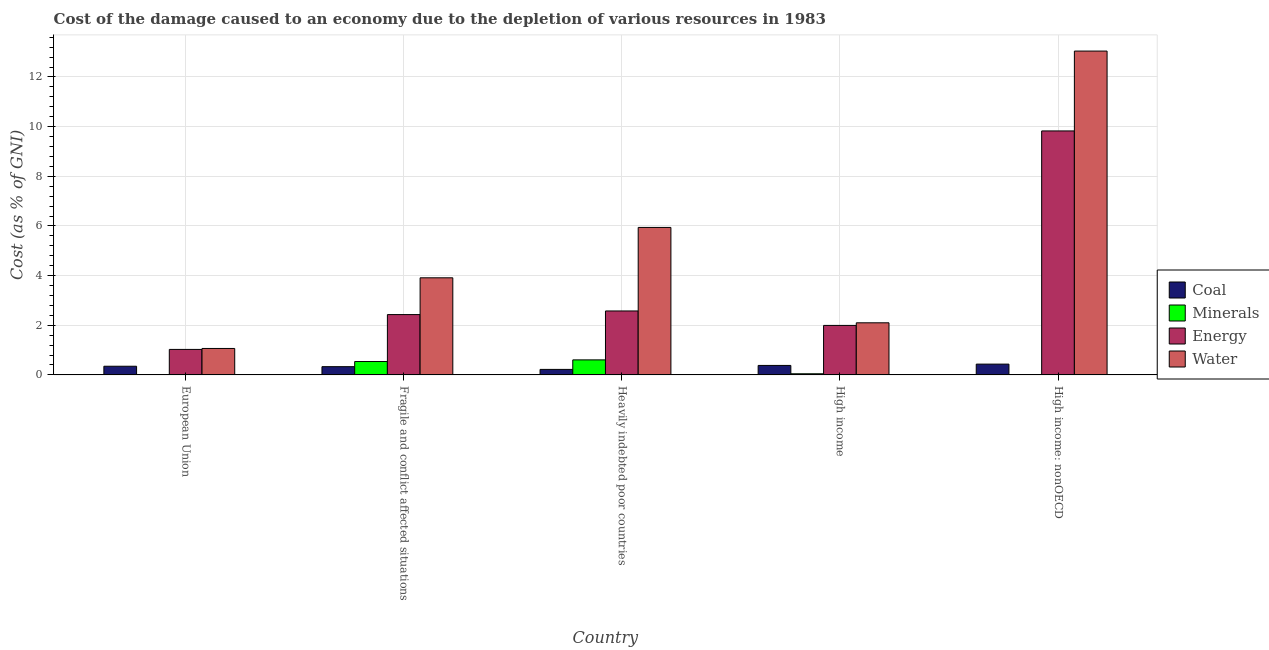How many bars are there on the 2nd tick from the left?
Offer a terse response. 4. In how many cases, is the number of bars for a given country not equal to the number of legend labels?
Give a very brief answer. 0. What is the cost of damage due to depletion of energy in Heavily indebted poor countries?
Your answer should be very brief. 2.58. Across all countries, what is the maximum cost of damage due to depletion of minerals?
Give a very brief answer. 0.61. Across all countries, what is the minimum cost of damage due to depletion of coal?
Make the answer very short. 0.22. In which country was the cost of damage due to depletion of minerals maximum?
Your answer should be very brief. Heavily indebted poor countries. In which country was the cost of damage due to depletion of minerals minimum?
Your response must be concise. European Union. What is the total cost of damage due to depletion of energy in the graph?
Your answer should be compact. 17.85. What is the difference between the cost of damage due to depletion of minerals in Fragile and conflict affected situations and that in High income?
Your answer should be compact. 0.49. What is the difference between the cost of damage due to depletion of water in High income and the cost of damage due to depletion of coal in Fragile and conflict affected situations?
Provide a short and direct response. 1.77. What is the average cost of damage due to depletion of water per country?
Your answer should be compact. 5.21. What is the difference between the cost of damage due to depletion of coal and cost of damage due to depletion of energy in Fragile and conflict affected situations?
Your response must be concise. -2.1. In how many countries, is the cost of damage due to depletion of energy greater than 12.4 %?
Provide a succinct answer. 0. What is the ratio of the cost of damage due to depletion of water in Heavily indebted poor countries to that in High income?
Offer a very short reply. 2.83. Is the difference between the cost of damage due to depletion of minerals in European Union and Heavily indebted poor countries greater than the difference between the cost of damage due to depletion of energy in European Union and Heavily indebted poor countries?
Give a very brief answer. Yes. What is the difference between the highest and the second highest cost of damage due to depletion of minerals?
Offer a terse response. 0.07. What is the difference between the highest and the lowest cost of damage due to depletion of water?
Offer a terse response. 11.98. Is the sum of the cost of damage due to depletion of energy in Fragile and conflict affected situations and High income greater than the maximum cost of damage due to depletion of water across all countries?
Provide a short and direct response. No. What does the 3rd bar from the left in High income represents?
Your answer should be compact. Energy. What does the 3rd bar from the right in High income: nonOECD represents?
Your answer should be very brief. Minerals. Are the values on the major ticks of Y-axis written in scientific E-notation?
Ensure brevity in your answer.  No. Does the graph contain any zero values?
Provide a succinct answer. No. Does the graph contain grids?
Provide a short and direct response. Yes. How many legend labels are there?
Ensure brevity in your answer.  4. What is the title of the graph?
Provide a short and direct response. Cost of the damage caused to an economy due to the depletion of various resources in 1983 . Does "Social Awareness" appear as one of the legend labels in the graph?
Your answer should be very brief. No. What is the label or title of the Y-axis?
Ensure brevity in your answer.  Cost (as % of GNI). What is the Cost (as % of GNI) in Coal in European Union?
Offer a very short reply. 0.35. What is the Cost (as % of GNI) of Minerals in European Union?
Make the answer very short. 0.01. What is the Cost (as % of GNI) of Energy in European Union?
Provide a short and direct response. 1.03. What is the Cost (as % of GNI) of Water in European Union?
Ensure brevity in your answer.  1.07. What is the Cost (as % of GNI) in Coal in Fragile and conflict affected situations?
Give a very brief answer. 0.33. What is the Cost (as % of GNI) in Minerals in Fragile and conflict affected situations?
Your answer should be compact. 0.54. What is the Cost (as % of GNI) in Energy in Fragile and conflict affected situations?
Provide a short and direct response. 2.43. What is the Cost (as % of GNI) of Water in Fragile and conflict affected situations?
Your response must be concise. 3.91. What is the Cost (as % of GNI) in Coal in Heavily indebted poor countries?
Offer a terse response. 0.22. What is the Cost (as % of GNI) of Minerals in Heavily indebted poor countries?
Offer a terse response. 0.61. What is the Cost (as % of GNI) in Energy in Heavily indebted poor countries?
Provide a short and direct response. 2.58. What is the Cost (as % of GNI) of Water in Heavily indebted poor countries?
Give a very brief answer. 5.94. What is the Cost (as % of GNI) in Coal in High income?
Offer a terse response. 0.38. What is the Cost (as % of GNI) of Minerals in High income?
Your answer should be very brief. 0.05. What is the Cost (as % of GNI) of Energy in High income?
Provide a short and direct response. 1.99. What is the Cost (as % of GNI) of Water in High income?
Your answer should be very brief. 2.1. What is the Cost (as % of GNI) in Coal in High income: nonOECD?
Offer a very short reply. 0.43. What is the Cost (as % of GNI) of Minerals in High income: nonOECD?
Your response must be concise. 0.01. What is the Cost (as % of GNI) of Energy in High income: nonOECD?
Your answer should be compact. 9.83. What is the Cost (as % of GNI) of Water in High income: nonOECD?
Provide a succinct answer. 13.04. Across all countries, what is the maximum Cost (as % of GNI) of Coal?
Give a very brief answer. 0.43. Across all countries, what is the maximum Cost (as % of GNI) of Minerals?
Keep it short and to the point. 0.61. Across all countries, what is the maximum Cost (as % of GNI) in Energy?
Offer a very short reply. 9.83. Across all countries, what is the maximum Cost (as % of GNI) in Water?
Your response must be concise. 13.04. Across all countries, what is the minimum Cost (as % of GNI) of Coal?
Provide a short and direct response. 0.22. Across all countries, what is the minimum Cost (as % of GNI) of Minerals?
Keep it short and to the point. 0.01. Across all countries, what is the minimum Cost (as % of GNI) in Energy?
Give a very brief answer. 1.03. Across all countries, what is the minimum Cost (as % of GNI) in Water?
Provide a short and direct response. 1.07. What is the total Cost (as % of GNI) in Coal in the graph?
Your response must be concise. 1.72. What is the total Cost (as % of GNI) of Minerals in the graph?
Make the answer very short. 1.21. What is the total Cost (as % of GNI) of Energy in the graph?
Offer a very short reply. 17.85. What is the total Cost (as % of GNI) of Water in the graph?
Provide a succinct answer. 26.06. What is the difference between the Cost (as % of GNI) in Coal in European Union and that in Fragile and conflict affected situations?
Keep it short and to the point. 0.02. What is the difference between the Cost (as % of GNI) of Minerals in European Union and that in Fragile and conflict affected situations?
Keep it short and to the point. -0.53. What is the difference between the Cost (as % of GNI) of Energy in European Union and that in Fragile and conflict affected situations?
Provide a succinct answer. -1.4. What is the difference between the Cost (as % of GNI) in Water in European Union and that in Fragile and conflict affected situations?
Your answer should be compact. -2.85. What is the difference between the Cost (as % of GNI) in Coal in European Union and that in Heavily indebted poor countries?
Give a very brief answer. 0.13. What is the difference between the Cost (as % of GNI) in Minerals in European Union and that in Heavily indebted poor countries?
Make the answer very short. -0.6. What is the difference between the Cost (as % of GNI) of Energy in European Union and that in Heavily indebted poor countries?
Ensure brevity in your answer.  -1.55. What is the difference between the Cost (as % of GNI) in Water in European Union and that in Heavily indebted poor countries?
Your answer should be very brief. -4.87. What is the difference between the Cost (as % of GNI) of Coal in European Union and that in High income?
Keep it short and to the point. -0.03. What is the difference between the Cost (as % of GNI) of Minerals in European Union and that in High income?
Provide a short and direct response. -0.04. What is the difference between the Cost (as % of GNI) of Energy in European Union and that in High income?
Your answer should be very brief. -0.97. What is the difference between the Cost (as % of GNI) in Water in European Union and that in High income?
Provide a short and direct response. -1.03. What is the difference between the Cost (as % of GNI) of Coal in European Union and that in High income: nonOECD?
Your response must be concise. -0.09. What is the difference between the Cost (as % of GNI) of Minerals in European Union and that in High income: nonOECD?
Make the answer very short. -0.01. What is the difference between the Cost (as % of GNI) in Energy in European Union and that in High income: nonOECD?
Ensure brevity in your answer.  -8.8. What is the difference between the Cost (as % of GNI) of Water in European Union and that in High income: nonOECD?
Provide a succinct answer. -11.98. What is the difference between the Cost (as % of GNI) of Coal in Fragile and conflict affected situations and that in Heavily indebted poor countries?
Your answer should be compact. 0.11. What is the difference between the Cost (as % of GNI) in Minerals in Fragile and conflict affected situations and that in Heavily indebted poor countries?
Offer a terse response. -0.07. What is the difference between the Cost (as % of GNI) in Energy in Fragile and conflict affected situations and that in Heavily indebted poor countries?
Give a very brief answer. -0.15. What is the difference between the Cost (as % of GNI) in Water in Fragile and conflict affected situations and that in Heavily indebted poor countries?
Offer a terse response. -2.03. What is the difference between the Cost (as % of GNI) of Coal in Fragile and conflict affected situations and that in High income?
Your answer should be very brief. -0.05. What is the difference between the Cost (as % of GNI) in Minerals in Fragile and conflict affected situations and that in High income?
Your answer should be very brief. 0.49. What is the difference between the Cost (as % of GNI) of Energy in Fragile and conflict affected situations and that in High income?
Provide a succinct answer. 0.44. What is the difference between the Cost (as % of GNI) of Water in Fragile and conflict affected situations and that in High income?
Give a very brief answer. 1.81. What is the difference between the Cost (as % of GNI) of Coal in Fragile and conflict affected situations and that in High income: nonOECD?
Provide a succinct answer. -0.1. What is the difference between the Cost (as % of GNI) of Minerals in Fragile and conflict affected situations and that in High income: nonOECD?
Ensure brevity in your answer.  0.53. What is the difference between the Cost (as % of GNI) of Energy in Fragile and conflict affected situations and that in High income: nonOECD?
Your answer should be very brief. -7.4. What is the difference between the Cost (as % of GNI) of Water in Fragile and conflict affected situations and that in High income: nonOECD?
Provide a short and direct response. -9.13. What is the difference between the Cost (as % of GNI) of Coal in Heavily indebted poor countries and that in High income?
Provide a short and direct response. -0.16. What is the difference between the Cost (as % of GNI) in Minerals in Heavily indebted poor countries and that in High income?
Offer a terse response. 0.56. What is the difference between the Cost (as % of GNI) of Energy in Heavily indebted poor countries and that in High income?
Give a very brief answer. 0.58. What is the difference between the Cost (as % of GNI) of Water in Heavily indebted poor countries and that in High income?
Give a very brief answer. 3.84. What is the difference between the Cost (as % of GNI) in Coal in Heavily indebted poor countries and that in High income: nonOECD?
Keep it short and to the point. -0.21. What is the difference between the Cost (as % of GNI) of Minerals in Heavily indebted poor countries and that in High income: nonOECD?
Ensure brevity in your answer.  0.59. What is the difference between the Cost (as % of GNI) in Energy in Heavily indebted poor countries and that in High income: nonOECD?
Offer a terse response. -7.25. What is the difference between the Cost (as % of GNI) of Water in Heavily indebted poor countries and that in High income: nonOECD?
Give a very brief answer. -7.1. What is the difference between the Cost (as % of GNI) in Coal in High income and that in High income: nonOECD?
Make the answer very short. -0.05. What is the difference between the Cost (as % of GNI) in Minerals in High income and that in High income: nonOECD?
Make the answer very short. 0.03. What is the difference between the Cost (as % of GNI) in Energy in High income and that in High income: nonOECD?
Offer a very short reply. -7.83. What is the difference between the Cost (as % of GNI) in Water in High income and that in High income: nonOECD?
Keep it short and to the point. -10.94. What is the difference between the Cost (as % of GNI) in Coal in European Union and the Cost (as % of GNI) in Minerals in Fragile and conflict affected situations?
Give a very brief answer. -0.19. What is the difference between the Cost (as % of GNI) in Coal in European Union and the Cost (as % of GNI) in Energy in Fragile and conflict affected situations?
Ensure brevity in your answer.  -2.08. What is the difference between the Cost (as % of GNI) of Coal in European Union and the Cost (as % of GNI) of Water in Fragile and conflict affected situations?
Keep it short and to the point. -3.56. What is the difference between the Cost (as % of GNI) in Minerals in European Union and the Cost (as % of GNI) in Energy in Fragile and conflict affected situations?
Your answer should be compact. -2.42. What is the difference between the Cost (as % of GNI) in Minerals in European Union and the Cost (as % of GNI) in Water in Fragile and conflict affected situations?
Your response must be concise. -3.9. What is the difference between the Cost (as % of GNI) of Energy in European Union and the Cost (as % of GNI) of Water in Fragile and conflict affected situations?
Provide a succinct answer. -2.88. What is the difference between the Cost (as % of GNI) of Coal in European Union and the Cost (as % of GNI) of Minerals in Heavily indebted poor countries?
Keep it short and to the point. -0.26. What is the difference between the Cost (as % of GNI) in Coal in European Union and the Cost (as % of GNI) in Energy in Heavily indebted poor countries?
Your response must be concise. -2.23. What is the difference between the Cost (as % of GNI) in Coal in European Union and the Cost (as % of GNI) in Water in Heavily indebted poor countries?
Your answer should be very brief. -5.59. What is the difference between the Cost (as % of GNI) in Minerals in European Union and the Cost (as % of GNI) in Energy in Heavily indebted poor countries?
Ensure brevity in your answer.  -2.57. What is the difference between the Cost (as % of GNI) in Minerals in European Union and the Cost (as % of GNI) in Water in Heavily indebted poor countries?
Offer a very short reply. -5.93. What is the difference between the Cost (as % of GNI) in Energy in European Union and the Cost (as % of GNI) in Water in Heavily indebted poor countries?
Your response must be concise. -4.91. What is the difference between the Cost (as % of GNI) in Coal in European Union and the Cost (as % of GNI) in Minerals in High income?
Keep it short and to the point. 0.3. What is the difference between the Cost (as % of GNI) of Coal in European Union and the Cost (as % of GNI) of Energy in High income?
Offer a terse response. -1.64. What is the difference between the Cost (as % of GNI) of Coal in European Union and the Cost (as % of GNI) of Water in High income?
Your response must be concise. -1.75. What is the difference between the Cost (as % of GNI) of Minerals in European Union and the Cost (as % of GNI) of Energy in High income?
Provide a short and direct response. -1.99. What is the difference between the Cost (as % of GNI) in Minerals in European Union and the Cost (as % of GNI) in Water in High income?
Your answer should be very brief. -2.09. What is the difference between the Cost (as % of GNI) in Energy in European Union and the Cost (as % of GNI) in Water in High income?
Provide a short and direct response. -1.07. What is the difference between the Cost (as % of GNI) in Coal in European Union and the Cost (as % of GNI) in Minerals in High income: nonOECD?
Provide a succinct answer. 0.34. What is the difference between the Cost (as % of GNI) of Coal in European Union and the Cost (as % of GNI) of Energy in High income: nonOECD?
Make the answer very short. -9.48. What is the difference between the Cost (as % of GNI) of Coal in European Union and the Cost (as % of GNI) of Water in High income: nonOECD?
Keep it short and to the point. -12.69. What is the difference between the Cost (as % of GNI) in Minerals in European Union and the Cost (as % of GNI) in Energy in High income: nonOECD?
Offer a very short reply. -9.82. What is the difference between the Cost (as % of GNI) of Minerals in European Union and the Cost (as % of GNI) of Water in High income: nonOECD?
Keep it short and to the point. -13.04. What is the difference between the Cost (as % of GNI) of Energy in European Union and the Cost (as % of GNI) of Water in High income: nonOECD?
Offer a terse response. -12.02. What is the difference between the Cost (as % of GNI) of Coal in Fragile and conflict affected situations and the Cost (as % of GNI) of Minerals in Heavily indebted poor countries?
Ensure brevity in your answer.  -0.27. What is the difference between the Cost (as % of GNI) of Coal in Fragile and conflict affected situations and the Cost (as % of GNI) of Energy in Heavily indebted poor countries?
Your answer should be compact. -2.24. What is the difference between the Cost (as % of GNI) in Coal in Fragile and conflict affected situations and the Cost (as % of GNI) in Water in Heavily indebted poor countries?
Offer a very short reply. -5.61. What is the difference between the Cost (as % of GNI) in Minerals in Fragile and conflict affected situations and the Cost (as % of GNI) in Energy in Heavily indebted poor countries?
Offer a very short reply. -2.04. What is the difference between the Cost (as % of GNI) in Minerals in Fragile and conflict affected situations and the Cost (as % of GNI) in Water in Heavily indebted poor countries?
Keep it short and to the point. -5.4. What is the difference between the Cost (as % of GNI) in Energy in Fragile and conflict affected situations and the Cost (as % of GNI) in Water in Heavily indebted poor countries?
Offer a terse response. -3.51. What is the difference between the Cost (as % of GNI) in Coal in Fragile and conflict affected situations and the Cost (as % of GNI) in Minerals in High income?
Provide a succinct answer. 0.29. What is the difference between the Cost (as % of GNI) in Coal in Fragile and conflict affected situations and the Cost (as % of GNI) in Energy in High income?
Give a very brief answer. -1.66. What is the difference between the Cost (as % of GNI) in Coal in Fragile and conflict affected situations and the Cost (as % of GNI) in Water in High income?
Your answer should be very brief. -1.77. What is the difference between the Cost (as % of GNI) of Minerals in Fragile and conflict affected situations and the Cost (as % of GNI) of Energy in High income?
Offer a very short reply. -1.45. What is the difference between the Cost (as % of GNI) of Minerals in Fragile and conflict affected situations and the Cost (as % of GNI) of Water in High income?
Offer a very short reply. -1.56. What is the difference between the Cost (as % of GNI) in Energy in Fragile and conflict affected situations and the Cost (as % of GNI) in Water in High income?
Make the answer very short. 0.33. What is the difference between the Cost (as % of GNI) in Coal in Fragile and conflict affected situations and the Cost (as % of GNI) in Minerals in High income: nonOECD?
Make the answer very short. 0.32. What is the difference between the Cost (as % of GNI) of Coal in Fragile and conflict affected situations and the Cost (as % of GNI) of Energy in High income: nonOECD?
Offer a very short reply. -9.49. What is the difference between the Cost (as % of GNI) of Coal in Fragile and conflict affected situations and the Cost (as % of GNI) of Water in High income: nonOECD?
Your answer should be very brief. -12.71. What is the difference between the Cost (as % of GNI) of Minerals in Fragile and conflict affected situations and the Cost (as % of GNI) of Energy in High income: nonOECD?
Give a very brief answer. -9.29. What is the difference between the Cost (as % of GNI) in Minerals in Fragile and conflict affected situations and the Cost (as % of GNI) in Water in High income: nonOECD?
Your answer should be very brief. -12.5. What is the difference between the Cost (as % of GNI) in Energy in Fragile and conflict affected situations and the Cost (as % of GNI) in Water in High income: nonOECD?
Offer a very short reply. -10.61. What is the difference between the Cost (as % of GNI) in Coal in Heavily indebted poor countries and the Cost (as % of GNI) in Minerals in High income?
Provide a short and direct response. 0.18. What is the difference between the Cost (as % of GNI) of Coal in Heavily indebted poor countries and the Cost (as % of GNI) of Energy in High income?
Offer a terse response. -1.77. What is the difference between the Cost (as % of GNI) in Coal in Heavily indebted poor countries and the Cost (as % of GNI) in Water in High income?
Provide a short and direct response. -1.88. What is the difference between the Cost (as % of GNI) in Minerals in Heavily indebted poor countries and the Cost (as % of GNI) in Energy in High income?
Offer a very short reply. -1.39. What is the difference between the Cost (as % of GNI) in Minerals in Heavily indebted poor countries and the Cost (as % of GNI) in Water in High income?
Provide a short and direct response. -1.49. What is the difference between the Cost (as % of GNI) of Energy in Heavily indebted poor countries and the Cost (as % of GNI) of Water in High income?
Your answer should be compact. 0.48. What is the difference between the Cost (as % of GNI) of Coal in Heavily indebted poor countries and the Cost (as % of GNI) of Minerals in High income: nonOECD?
Offer a terse response. 0.21. What is the difference between the Cost (as % of GNI) of Coal in Heavily indebted poor countries and the Cost (as % of GNI) of Energy in High income: nonOECD?
Provide a succinct answer. -9.6. What is the difference between the Cost (as % of GNI) in Coal in Heavily indebted poor countries and the Cost (as % of GNI) in Water in High income: nonOECD?
Provide a succinct answer. -12.82. What is the difference between the Cost (as % of GNI) of Minerals in Heavily indebted poor countries and the Cost (as % of GNI) of Energy in High income: nonOECD?
Give a very brief answer. -9.22. What is the difference between the Cost (as % of GNI) of Minerals in Heavily indebted poor countries and the Cost (as % of GNI) of Water in High income: nonOECD?
Your answer should be very brief. -12.44. What is the difference between the Cost (as % of GNI) of Energy in Heavily indebted poor countries and the Cost (as % of GNI) of Water in High income: nonOECD?
Your response must be concise. -10.47. What is the difference between the Cost (as % of GNI) of Coal in High income and the Cost (as % of GNI) of Minerals in High income: nonOECD?
Provide a succinct answer. 0.37. What is the difference between the Cost (as % of GNI) in Coal in High income and the Cost (as % of GNI) in Energy in High income: nonOECD?
Keep it short and to the point. -9.44. What is the difference between the Cost (as % of GNI) of Coal in High income and the Cost (as % of GNI) of Water in High income: nonOECD?
Keep it short and to the point. -12.66. What is the difference between the Cost (as % of GNI) in Minerals in High income and the Cost (as % of GNI) in Energy in High income: nonOECD?
Give a very brief answer. -9.78. What is the difference between the Cost (as % of GNI) of Minerals in High income and the Cost (as % of GNI) of Water in High income: nonOECD?
Offer a terse response. -13. What is the difference between the Cost (as % of GNI) of Energy in High income and the Cost (as % of GNI) of Water in High income: nonOECD?
Offer a terse response. -11.05. What is the average Cost (as % of GNI) in Coal per country?
Offer a very short reply. 0.34. What is the average Cost (as % of GNI) in Minerals per country?
Provide a short and direct response. 0.24. What is the average Cost (as % of GNI) of Energy per country?
Give a very brief answer. 3.57. What is the average Cost (as % of GNI) in Water per country?
Your answer should be very brief. 5.21. What is the difference between the Cost (as % of GNI) of Coal and Cost (as % of GNI) of Minerals in European Union?
Provide a short and direct response. 0.34. What is the difference between the Cost (as % of GNI) in Coal and Cost (as % of GNI) in Energy in European Union?
Make the answer very short. -0.68. What is the difference between the Cost (as % of GNI) in Coal and Cost (as % of GNI) in Water in European Union?
Give a very brief answer. -0.72. What is the difference between the Cost (as % of GNI) of Minerals and Cost (as % of GNI) of Energy in European Union?
Give a very brief answer. -1.02. What is the difference between the Cost (as % of GNI) of Minerals and Cost (as % of GNI) of Water in European Union?
Keep it short and to the point. -1.06. What is the difference between the Cost (as % of GNI) of Energy and Cost (as % of GNI) of Water in European Union?
Ensure brevity in your answer.  -0.04. What is the difference between the Cost (as % of GNI) of Coal and Cost (as % of GNI) of Minerals in Fragile and conflict affected situations?
Ensure brevity in your answer.  -0.21. What is the difference between the Cost (as % of GNI) of Coal and Cost (as % of GNI) of Energy in Fragile and conflict affected situations?
Provide a short and direct response. -2.1. What is the difference between the Cost (as % of GNI) of Coal and Cost (as % of GNI) of Water in Fragile and conflict affected situations?
Your response must be concise. -3.58. What is the difference between the Cost (as % of GNI) in Minerals and Cost (as % of GNI) in Energy in Fragile and conflict affected situations?
Give a very brief answer. -1.89. What is the difference between the Cost (as % of GNI) of Minerals and Cost (as % of GNI) of Water in Fragile and conflict affected situations?
Give a very brief answer. -3.37. What is the difference between the Cost (as % of GNI) in Energy and Cost (as % of GNI) in Water in Fragile and conflict affected situations?
Provide a short and direct response. -1.48. What is the difference between the Cost (as % of GNI) of Coal and Cost (as % of GNI) of Minerals in Heavily indebted poor countries?
Keep it short and to the point. -0.38. What is the difference between the Cost (as % of GNI) of Coal and Cost (as % of GNI) of Energy in Heavily indebted poor countries?
Your answer should be very brief. -2.35. What is the difference between the Cost (as % of GNI) in Coal and Cost (as % of GNI) in Water in Heavily indebted poor countries?
Offer a very short reply. -5.72. What is the difference between the Cost (as % of GNI) in Minerals and Cost (as % of GNI) in Energy in Heavily indebted poor countries?
Give a very brief answer. -1.97. What is the difference between the Cost (as % of GNI) of Minerals and Cost (as % of GNI) of Water in Heavily indebted poor countries?
Your answer should be compact. -5.33. What is the difference between the Cost (as % of GNI) of Energy and Cost (as % of GNI) of Water in Heavily indebted poor countries?
Provide a succinct answer. -3.36. What is the difference between the Cost (as % of GNI) of Coal and Cost (as % of GNI) of Minerals in High income?
Your response must be concise. 0.34. What is the difference between the Cost (as % of GNI) in Coal and Cost (as % of GNI) in Energy in High income?
Ensure brevity in your answer.  -1.61. What is the difference between the Cost (as % of GNI) of Coal and Cost (as % of GNI) of Water in High income?
Offer a very short reply. -1.72. What is the difference between the Cost (as % of GNI) of Minerals and Cost (as % of GNI) of Energy in High income?
Keep it short and to the point. -1.95. What is the difference between the Cost (as % of GNI) in Minerals and Cost (as % of GNI) in Water in High income?
Give a very brief answer. -2.05. What is the difference between the Cost (as % of GNI) of Energy and Cost (as % of GNI) of Water in High income?
Your response must be concise. -0.11. What is the difference between the Cost (as % of GNI) in Coal and Cost (as % of GNI) in Minerals in High income: nonOECD?
Make the answer very short. 0.42. What is the difference between the Cost (as % of GNI) of Coal and Cost (as % of GNI) of Energy in High income: nonOECD?
Provide a short and direct response. -9.39. What is the difference between the Cost (as % of GNI) of Coal and Cost (as % of GNI) of Water in High income: nonOECD?
Keep it short and to the point. -12.61. What is the difference between the Cost (as % of GNI) of Minerals and Cost (as % of GNI) of Energy in High income: nonOECD?
Keep it short and to the point. -9.81. What is the difference between the Cost (as % of GNI) of Minerals and Cost (as % of GNI) of Water in High income: nonOECD?
Your response must be concise. -13.03. What is the difference between the Cost (as % of GNI) of Energy and Cost (as % of GNI) of Water in High income: nonOECD?
Offer a terse response. -3.22. What is the ratio of the Cost (as % of GNI) of Coal in European Union to that in Fragile and conflict affected situations?
Ensure brevity in your answer.  1.05. What is the ratio of the Cost (as % of GNI) of Minerals in European Union to that in Fragile and conflict affected situations?
Make the answer very short. 0.01. What is the ratio of the Cost (as % of GNI) in Energy in European Union to that in Fragile and conflict affected situations?
Keep it short and to the point. 0.42. What is the ratio of the Cost (as % of GNI) in Water in European Union to that in Fragile and conflict affected situations?
Your response must be concise. 0.27. What is the ratio of the Cost (as % of GNI) of Coal in European Union to that in Heavily indebted poor countries?
Offer a very short reply. 1.57. What is the ratio of the Cost (as % of GNI) of Minerals in European Union to that in Heavily indebted poor countries?
Your answer should be compact. 0.01. What is the ratio of the Cost (as % of GNI) of Energy in European Union to that in Heavily indebted poor countries?
Give a very brief answer. 0.4. What is the ratio of the Cost (as % of GNI) of Water in European Union to that in Heavily indebted poor countries?
Provide a succinct answer. 0.18. What is the ratio of the Cost (as % of GNI) of Coal in European Union to that in High income?
Keep it short and to the point. 0.91. What is the ratio of the Cost (as % of GNI) of Minerals in European Union to that in High income?
Make the answer very short. 0.14. What is the ratio of the Cost (as % of GNI) in Energy in European Union to that in High income?
Offer a very short reply. 0.51. What is the ratio of the Cost (as % of GNI) in Water in European Union to that in High income?
Your answer should be very brief. 0.51. What is the ratio of the Cost (as % of GNI) in Coal in European Union to that in High income: nonOECD?
Ensure brevity in your answer.  0.8. What is the ratio of the Cost (as % of GNI) of Minerals in European Union to that in High income: nonOECD?
Give a very brief answer. 0.48. What is the ratio of the Cost (as % of GNI) of Energy in European Union to that in High income: nonOECD?
Make the answer very short. 0.1. What is the ratio of the Cost (as % of GNI) in Water in European Union to that in High income: nonOECD?
Your answer should be very brief. 0.08. What is the ratio of the Cost (as % of GNI) of Coal in Fragile and conflict affected situations to that in Heavily indebted poor countries?
Make the answer very short. 1.5. What is the ratio of the Cost (as % of GNI) in Minerals in Fragile and conflict affected situations to that in Heavily indebted poor countries?
Provide a short and direct response. 0.89. What is the ratio of the Cost (as % of GNI) in Energy in Fragile and conflict affected situations to that in Heavily indebted poor countries?
Offer a very short reply. 0.94. What is the ratio of the Cost (as % of GNI) of Water in Fragile and conflict affected situations to that in Heavily indebted poor countries?
Your response must be concise. 0.66. What is the ratio of the Cost (as % of GNI) in Coal in Fragile and conflict affected situations to that in High income?
Your answer should be compact. 0.87. What is the ratio of the Cost (as % of GNI) of Minerals in Fragile and conflict affected situations to that in High income?
Make the answer very short. 11.77. What is the ratio of the Cost (as % of GNI) of Energy in Fragile and conflict affected situations to that in High income?
Ensure brevity in your answer.  1.22. What is the ratio of the Cost (as % of GNI) in Water in Fragile and conflict affected situations to that in High income?
Provide a succinct answer. 1.86. What is the ratio of the Cost (as % of GNI) of Coal in Fragile and conflict affected situations to that in High income: nonOECD?
Keep it short and to the point. 0.76. What is the ratio of the Cost (as % of GNI) of Minerals in Fragile and conflict affected situations to that in High income: nonOECD?
Offer a terse response. 41.66. What is the ratio of the Cost (as % of GNI) in Energy in Fragile and conflict affected situations to that in High income: nonOECD?
Your answer should be compact. 0.25. What is the ratio of the Cost (as % of GNI) in Water in Fragile and conflict affected situations to that in High income: nonOECD?
Keep it short and to the point. 0.3. What is the ratio of the Cost (as % of GNI) of Coal in Heavily indebted poor countries to that in High income?
Keep it short and to the point. 0.58. What is the ratio of the Cost (as % of GNI) in Minerals in Heavily indebted poor countries to that in High income?
Your response must be concise. 13.21. What is the ratio of the Cost (as % of GNI) of Energy in Heavily indebted poor countries to that in High income?
Your answer should be very brief. 1.29. What is the ratio of the Cost (as % of GNI) in Water in Heavily indebted poor countries to that in High income?
Keep it short and to the point. 2.83. What is the ratio of the Cost (as % of GNI) in Coal in Heavily indebted poor countries to that in High income: nonOECD?
Ensure brevity in your answer.  0.51. What is the ratio of the Cost (as % of GNI) in Minerals in Heavily indebted poor countries to that in High income: nonOECD?
Offer a terse response. 46.76. What is the ratio of the Cost (as % of GNI) in Energy in Heavily indebted poor countries to that in High income: nonOECD?
Give a very brief answer. 0.26. What is the ratio of the Cost (as % of GNI) of Water in Heavily indebted poor countries to that in High income: nonOECD?
Give a very brief answer. 0.46. What is the ratio of the Cost (as % of GNI) in Coal in High income to that in High income: nonOECD?
Ensure brevity in your answer.  0.88. What is the ratio of the Cost (as % of GNI) of Minerals in High income to that in High income: nonOECD?
Offer a terse response. 3.54. What is the ratio of the Cost (as % of GNI) in Energy in High income to that in High income: nonOECD?
Offer a terse response. 0.2. What is the ratio of the Cost (as % of GNI) in Water in High income to that in High income: nonOECD?
Your answer should be very brief. 0.16. What is the difference between the highest and the second highest Cost (as % of GNI) of Coal?
Offer a terse response. 0.05. What is the difference between the highest and the second highest Cost (as % of GNI) in Minerals?
Ensure brevity in your answer.  0.07. What is the difference between the highest and the second highest Cost (as % of GNI) of Energy?
Provide a succinct answer. 7.25. What is the difference between the highest and the second highest Cost (as % of GNI) of Water?
Provide a succinct answer. 7.1. What is the difference between the highest and the lowest Cost (as % of GNI) of Coal?
Offer a very short reply. 0.21. What is the difference between the highest and the lowest Cost (as % of GNI) in Minerals?
Keep it short and to the point. 0.6. What is the difference between the highest and the lowest Cost (as % of GNI) of Energy?
Offer a terse response. 8.8. What is the difference between the highest and the lowest Cost (as % of GNI) in Water?
Make the answer very short. 11.98. 